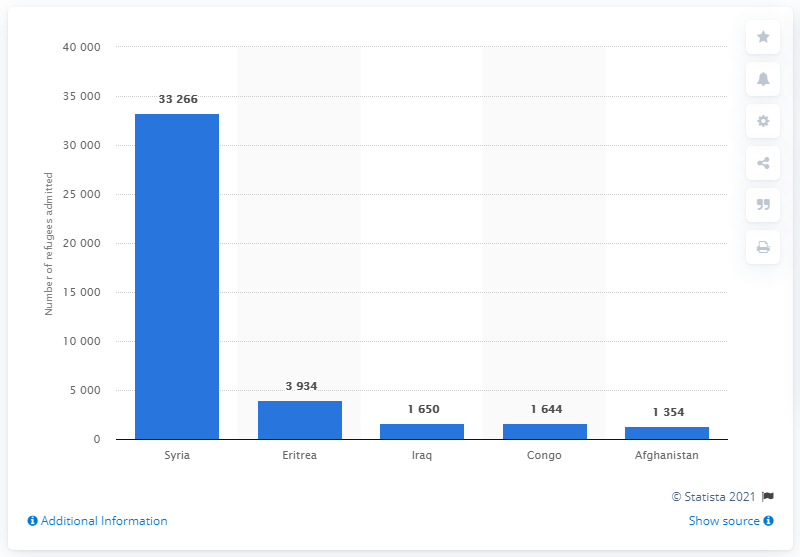Point out several critical features in this image. In 2016, Syria was the country that admitted the most refugees to Canada. 